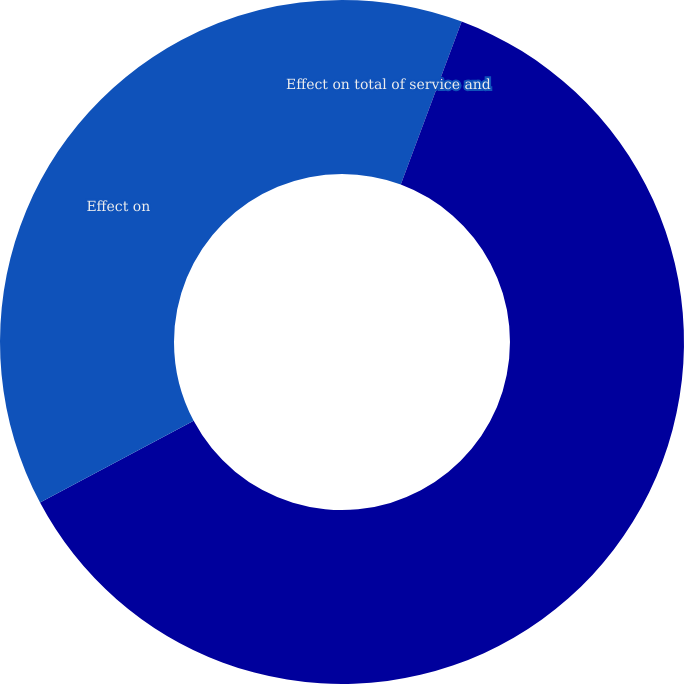Convert chart to OTSL. <chart><loc_0><loc_0><loc_500><loc_500><pie_chart><fcel>Effect on total of service and<fcel>Unnamed: 1<fcel>Effect on<nl><fcel>5.69%<fcel>61.54%<fcel>32.78%<nl></chart> 